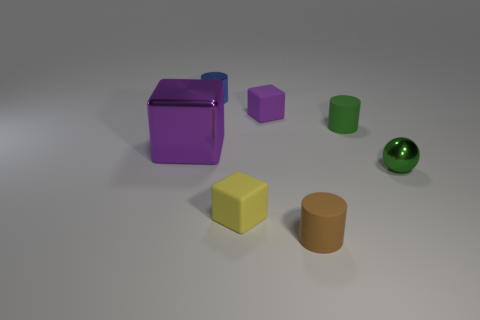What number of purple objects are either small shiny cubes or matte things?
Ensure brevity in your answer.  1. There is a tiny green object that is behind the big object; what material is it?
Make the answer very short. Rubber. Is the number of purple blocks greater than the number of green spheres?
Provide a short and direct response. Yes. Is the shape of the metal thing that is on the left side of the blue thing the same as  the yellow object?
Provide a short and direct response. Yes. How many tiny objects are behind the tiny yellow cube and on the left side of the tiny green ball?
Your answer should be very brief. 3. How many small brown rubber objects have the same shape as the blue shiny thing?
Make the answer very short. 1. What color is the cylinder behind the purple cube behind the big purple thing?
Make the answer very short. Blue. Is the shape of the purple rubber object the same as the green thing that is in front of the purple shiny block?
Offer a terse response. No. There is a small green thing behind the ball that is right of the matte block that is in front of the tiny shiny ball; what is its material?
Provide a succinct answer. Rubber. Is there a brown cylinder of the same size as the brown rubber thing?
Provide a short and direct response. No. 